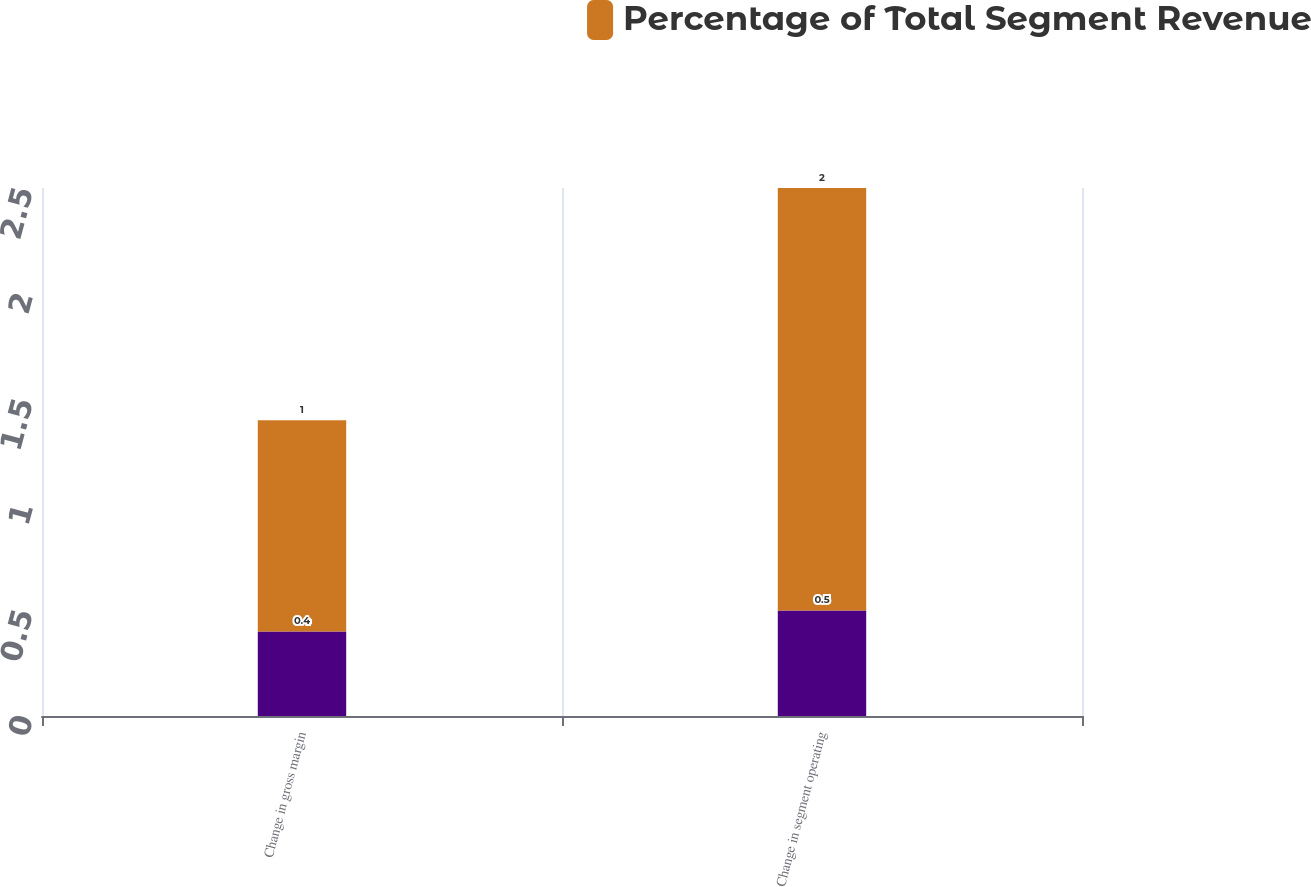<chart> <loc_0><loc_0><loc_500><loc_500><stacked_bar_chart><ecel><fcel>Change in gross margin<fcel>Change in segment operating<nl><fcel>nan<fcel>0.4<fcel>0.5<nl><fcel>Percentage of Total Segment Revenue<fcel>1<fcel>2<nl></chart> 